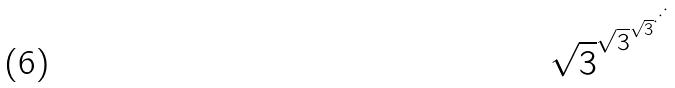<formula> <loc_0><loc_0><loc_500><loc_500>\sqrt { 3 } ^ { \sqrt { 3 } ^ { \sqrt { 3 } ^ { \cdot ^ { \cdot ^ { \cdot } } } } }</formula> 